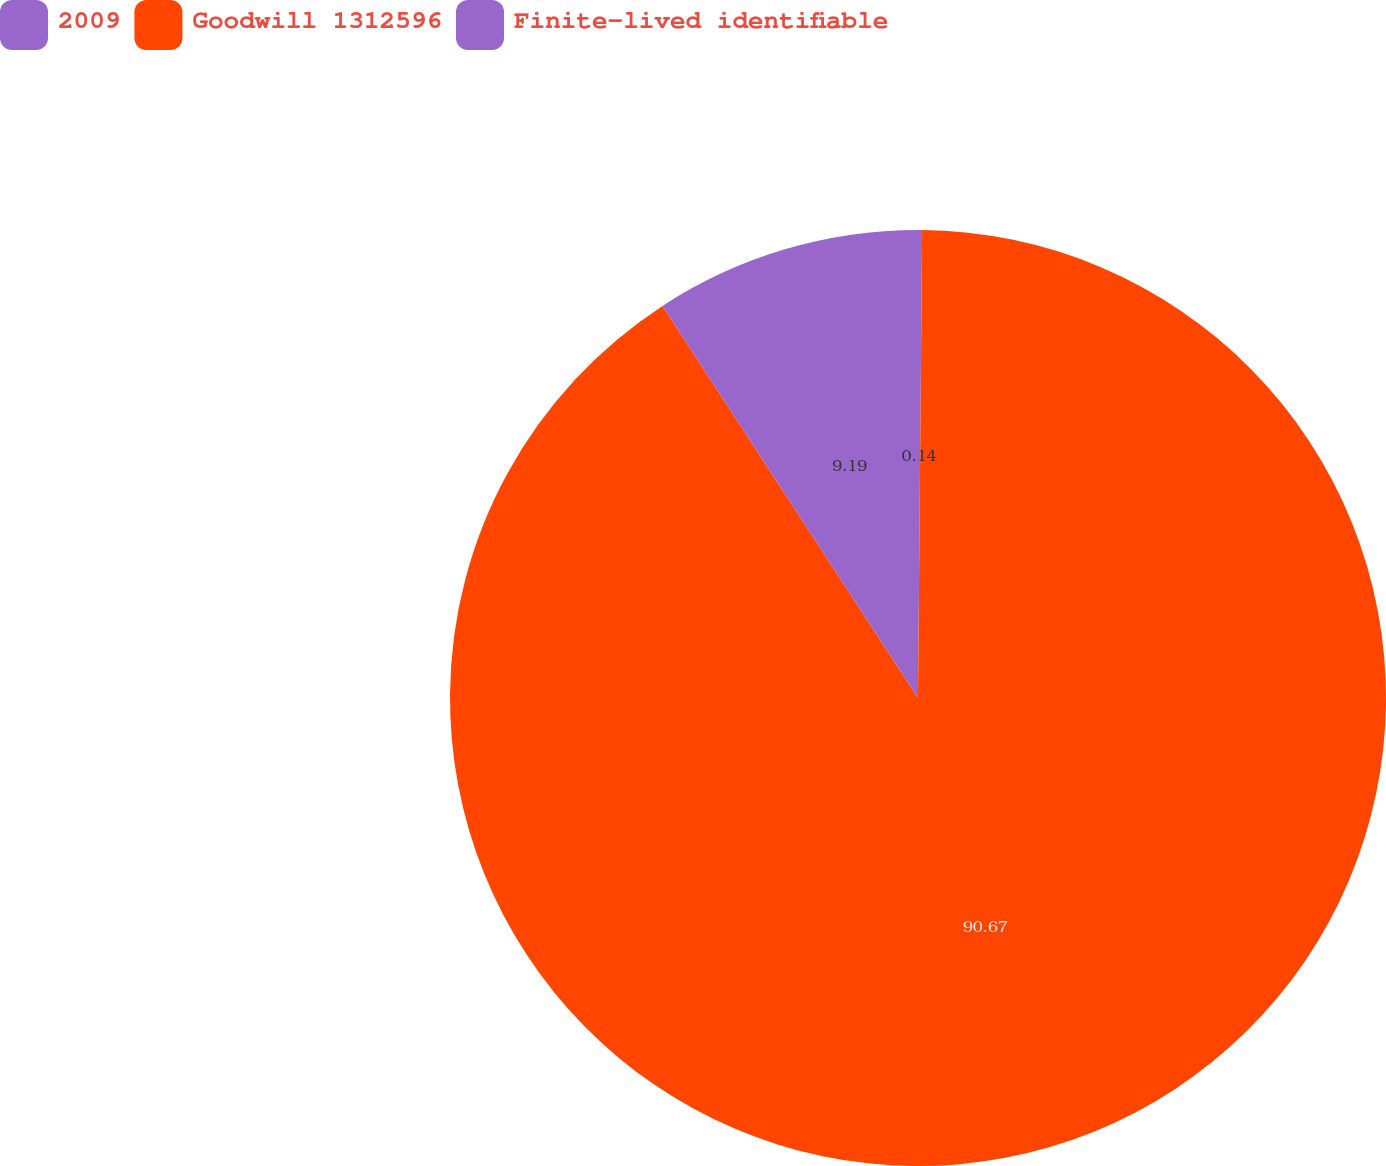Convert chart to OTSL. <chart><loc_0><loc_0><loc_500><loc_500><pie_chart><fcel>2009<fcel>Goodwill 1312596<fcel>Finite-lived identifiable<nl><fcel>0.14%<fcel>90.66%<fcel>9.19%<nl></chart> 